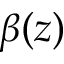Convert formula to latex. <formula><loc_0><loc_0><loc_500><loc_500>\beta ( z )</formula> 